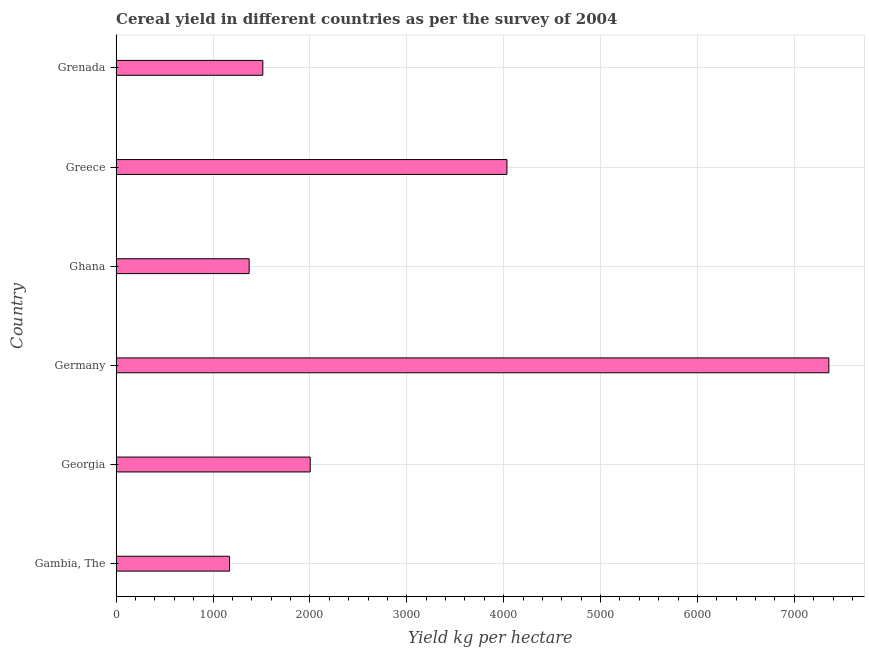Does the graph contain any zero values?
Make the answer very short. No. What is the title of the graph?
Make the answer very short. Cereal yield in different countries as per the survey of 2004. What is the label or title of the X-axis?
Offer a very short reply. Yield kg per hectare. What is the cereal yield in Germany?
Offer a terse response. 7357.23. Across all countries, what is the maximum cereal yield?
Ensure brevity in your answer.  7357.23. Across all countries, what is the minimum cereal yield?
Provide a succinct answer. 1170.76. In which country was the cereal yield minimum?
Provide a succinct answer. Gambia, The. What is the sum of the cereal yield?
Your answer should be very brief. 1.75e+04. What is the difference between the cereal yield in Georgia and Greece?
Make the answer very short. -2030.55. What is the average cereal yield per country?
Offer a very short reply. 2908.83. What is the median cereal yield?
Your answer should be very brief. 1758.85. In how many countries, is the cereal yield greater than 3200 kg per hectare?
Ensure brevity in your answer.  2. What is the ratio of the cereal yield in Germany to that in Greece?
Make the answer very short. 1.82. Is the cereal yield in Georgia less than that in Greece?
Provide a short and direct response. Yes. Is the difference between the cereal yield in Ghana and Greece greater than the difference between any two countries?
Offer a terse response. No. What is the difference between the highest and the second highest cereal yield?
Give a very brief answer. 3323.26. What is the difference between the highest and the lowest cereal yield?
Ensure brevity in your answer.  6186.47. In how many countries, is the cereal yield greater than the average cereal yield taken over all countries?
Offer a very short reply. 2. How many bars are there?
Make the answer very short. 6. Are all the bars in the graph horizontal?
Provide a short and direct response. Yes. What is the Yield kg per hectare of Gambia, The?
Your response must be concise. 1170.76. What is the Yield kg per hectare in Georgia?
Ensure brevity in your answer.  2003.42. What is the Yield kg per hectare of Germany?
Give a very brief answer. 7357.23. What is the Yield kg per hectare in Ghana?
Your answer should be compact. 1373.32. What is the Yield kg per hectare in Greece?
Your answer should be very brief. 4033.97. What is the Yield kg per hectare of Grenada?
Offer a terse response. 1514.29. What is the difference between the Yield kg per hectare in Gambia, The and Georgia?
Your answer should be compact. -832.66. What is the difference between the Yield kg per hectare in Gambia, The and Germany?
Your answer should be very brief. -6186.47. What is the difference between the Yield kg per hectare in Gambia, The and Ghana?
Your response must be concise. -202.56. What is the difference between the Yield kg per hectare in Gambia, The and Greece?
Provide a succinct answer. -2863.22. What is the difference between the Yield kg per hectare in Gambia, The and Grenada?
Make the answer very short. -343.53. What is the difference between the Yield kg per hectare in Georgia and Germany?
Your response must be concise. -5353.81. What is the difference between the Yield kg per hectare in Georgia and Ghana?
Provide a succinct answer. 630.1. What is the difference between the Yield kg per hectare in Georgia and Greece?
Ensure brevity in your answer.  -2030.55. What is the difference between the Yield kg per hectare in Georgia and Grenada?
Your answer should be compact. 489.13. What is the difference between the Yield kg per hectare in Germany and Ghana?
Offer a terse response. 5983.91. What is the difference between the Yield kg per hectare in Germany and Greece?
Offer a very short reply. 3323.26. What is the difference between the Yield kg per hectare in Germany and Grenada?
Keep it short and to the point. 5842.94. What is the difference between the Yield kg per hectare in Ghana and Greece?
Offer a terse response. -2660.65. What is the difference between the Yield kg per hectare in Ghana and Grenada?
Provide a short and direct response. -140.97. What is the difference between the Yield kg per hectare in Greece and Grenada?
Make the answer very short. 2519.69. What is the ratio of the Yield kg per hectare in Gambia, The to that in Georgia?
Ensure brevity in your answer.  0.58. What is the ratio of the Yield kg per hectare in Gambia, The to that in Germany?
Your response must be concise. 0.16. What is the ratio of the Yield kg per hectare in Gambia, The to that in Ghana?
Make the answer very short. 0.85. What is the ratio of the Yield kg per hectare in Gambia, The to that in Greece?
Make the answer very short. 0.29. What is the ratio of the Yield kg per hectare in Gambia, The to that in Grenada?
Offer a very short reply. 0.77. What is the ratio of the Yield kg per hectare in Georgia to that in Germany?
Offer a very short reply. 0.27. What is the ratio of the Yield kg per hectare in Georgia to that in Ghana?
Make the answer very short. 1.46. What is the ratio of the Yield kg per hectare in Georgia to that in Greece?
Provide a succinct answer. 0.5. What is the ratio of the Yield kg per hectare in Georgia to that in Grenada?
Keep it short and to the point. 1.32. What is the ratio of the Yield kg per hectare in Germany to that in Ghana?
Your answer should be very brief. 5.36. What is the ratio of the Yield kg per hectare in Germany to that in Greece?
Your answer should be compact. 1.82. What is the ratio of the Yield kg per hectare in Germany to that in Grenada?
Offer a very short reply. 4.86. What is the ratio of the Yield kg per hectare in Ghana to that in Greece?
Your response must be concise. 0.34. What is the ratio of the Yield kg per hectare in Ghana to that in Grenada?
Give a very brief answer. 0.91. What is the ratio of the Yield kg per hectare in Greece to that in Grenada?
Make the answer very short. 2.66. 